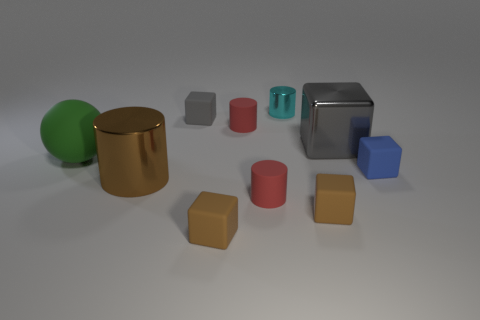Subtract all rubber blocks. How many blocks are left? 1 Subtract all green cylinders. How many gray cubes are left? 2 Subtract all brown cylinders. How many cylinders are left? 3 Subtract 4 cubes. How many cubes are left? 1 Subtract all cylinders. How many objects are left? 6 Add 5 tiny blue matte cubes. How many tiny blue matte cubes are left? 6 Add 6 brown blocks. How many brown blocks exist? 8 Subtract 0 purple cubes. How many objects are left? 10 Subtract all cyan blocks. Subtract all purple cylinders. How many blocks are left? 5 Subtract all tiny blue rubber spheres. Subtract all green rubber spheres. How many objects are left? 9 